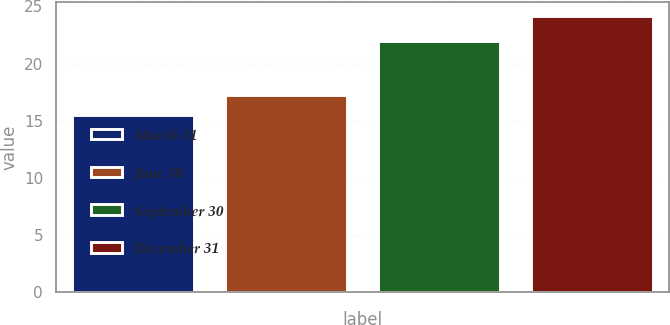<chart> <loc_0><loc_0><loc_500><loc_500><bar_chart><fcel>March 31<fcel>June 30<fcel>September 30<fcel>December 31<nl><fcel>15.49<fcel>17.24<fcel>21.99<fcel>24.18<nl></chart> 